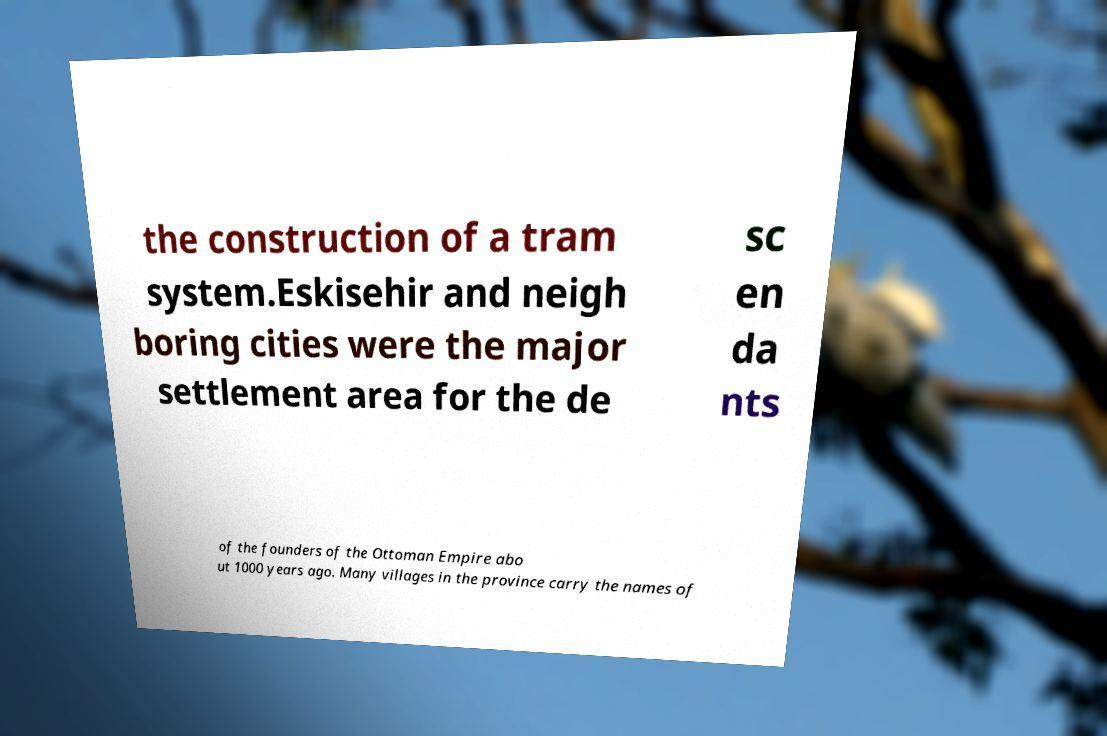Could you extract and type out the text from this image? the construction of a tram system.Eskisehir and neigh boring cities were the major settlement area for the de sc en da nts of the founders of the Ottoman Empire abo ut 1000 years ago. Many villages in the province carry the names of 